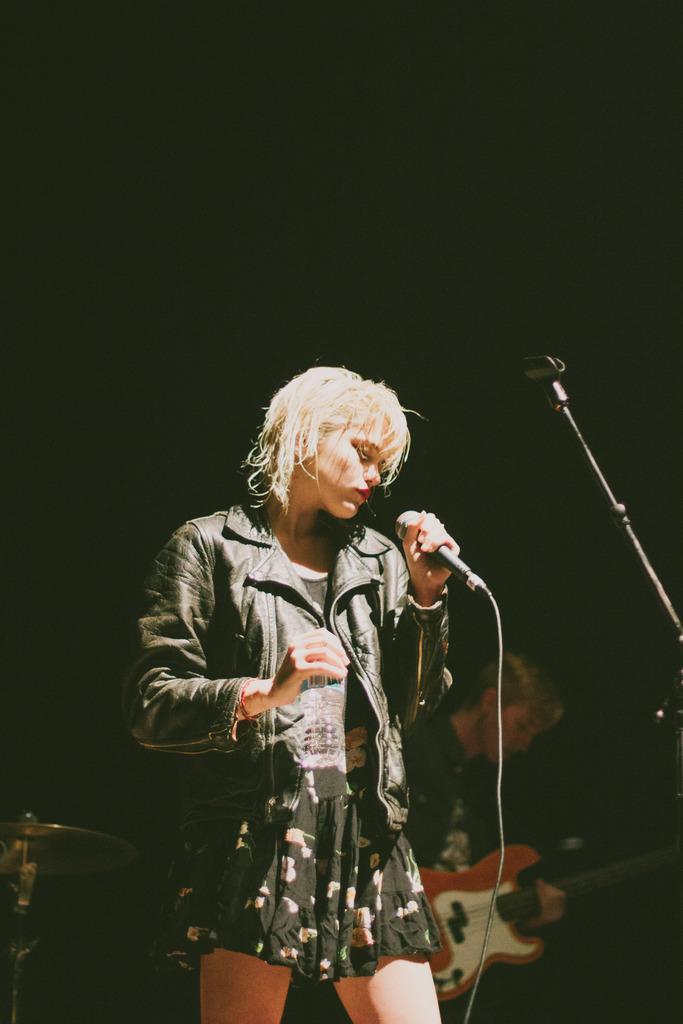In one or two sentences, can you explain what this image depicts? In the image we can see there is a woman who is holding a mike in her hand and behind her there is a person who is holding a guitar. 